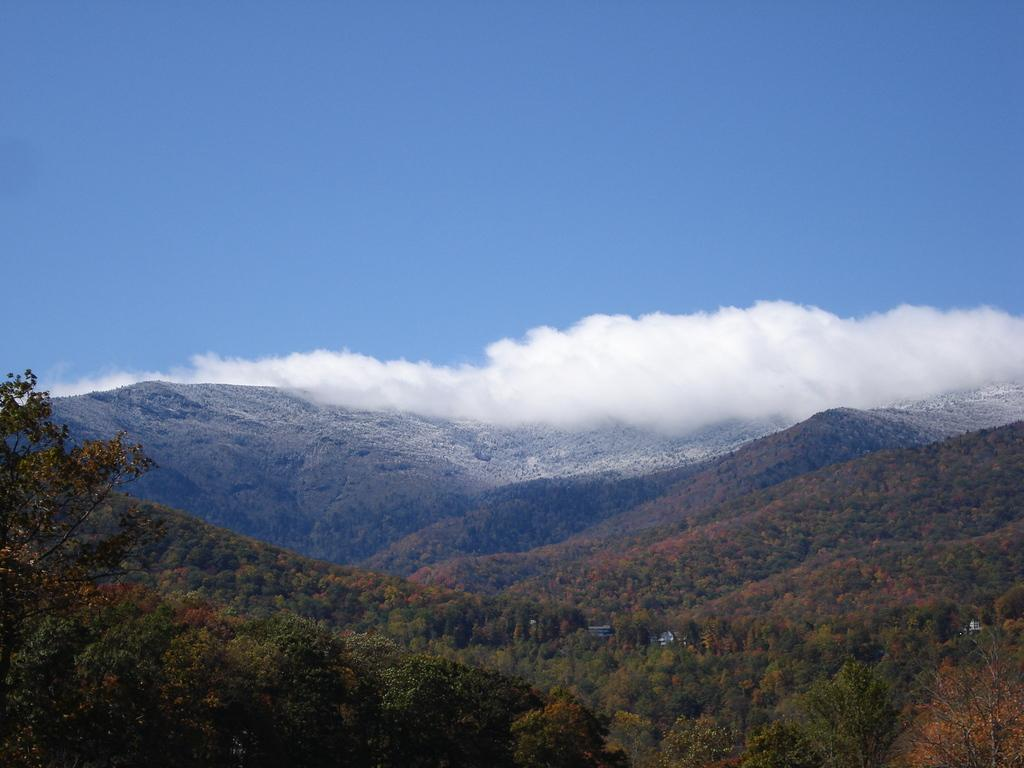What type of living organisms can be seen in the image? Plants can be seen in the image. What type of structures are present in the image? There are houses in the image. What natural landmarks can be seen in the background of the image? Mountains are visible in the background of the image. How would you describe the sky in the image? The sky is blue and cloudy in the image. What type of music is being played by the representative in the image? There is no representative or music present in the image; it features plants, houses, mountains, and a blue and cloudy sky. 